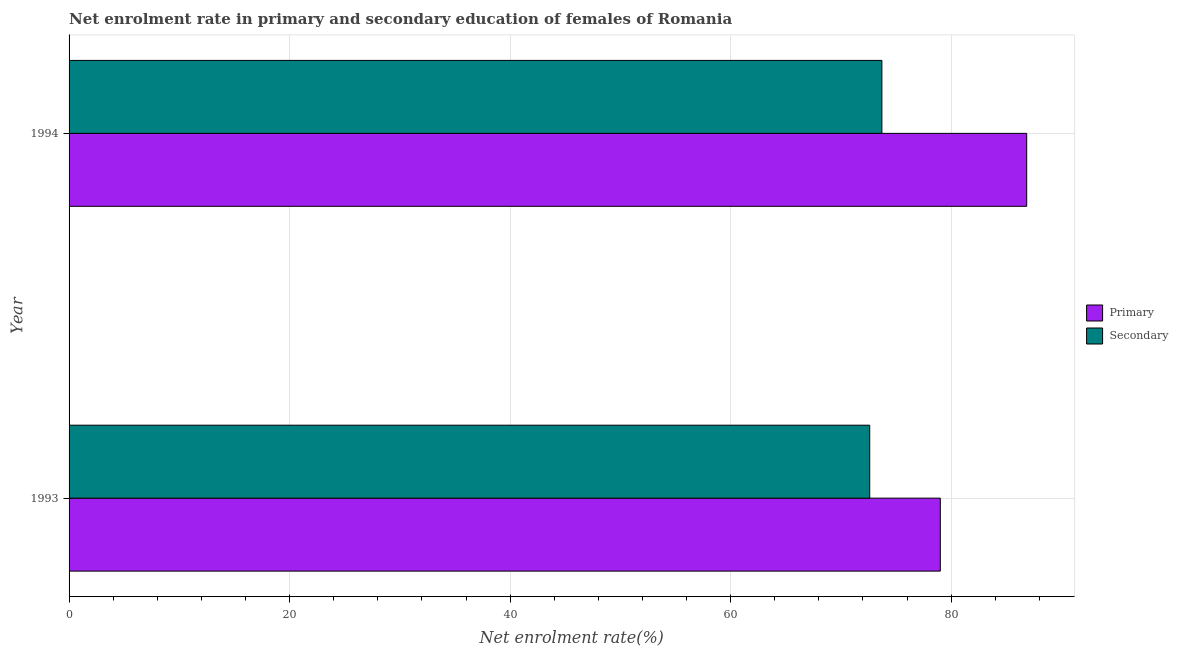How many groups of bars are there?
Make the answer very short. 2. Are the number of bars per tick equal to the number of legend labels?
Your answer should be compact. Yes. What is the enrollment rate in primary education in 1993?
Provide a short and direct response. 79.02. Across all years, what is the maximum enrollment rate in primary education?
Your answer should be very brief. 86.86. Across all years, what is the minimum enrollment rate in primary education?
Ensure brevity in your answer.  79.02. In which year was the enrollment rate in primary education minimum?
Offer a very short reply. 1993. What is the total enrollment rate in primary education in the graph?
Your answer should be very brief. 165.88. What is the difference between the enrollment rate in secondary education in 1993 and that in 1994?
Your response must be concise. -1.1. What is the difference between the enrollment rate in secondary education in 1994 and the enrollment rate in primary education in 1993?
Ensure brevity in your answer.  -5.3. What is the average enrollment rate in secondary education per year?
Your answer should be very brief. 73.17. In the year 1994, what is the difference between the enrollment rate in primary education and enrollment rate in secondary education?
Ensure brevity in your answer.  13.13. In how many years, is the enrollment rate in secondary education greater than 60 %?
Your response must be concise. 2. What is the ratio of the enrollment rate in primary education in 1993 to that in 1994?
Make the answer very short. 0.91. What does the 1st bar from the top in 1994 represents?
Ensure brevity in your answer.  Secondary. What does the 2nd bar from the bottom in 1994 represents?
Your answer should be very brief. Secondary. How many bars are there?
Offer a very short reply. 4. How many years are there in the graph?
Ensure brevity in your answer.  2. Are the values on the major ticks of X-axis written in scientific E-notation?
Your answer should be compact. No. How many legend labels are there?
Ensure brevity in your answer.  2. How are the legend labels stacked?
Offer a terse response. Vertical. What is the title of the graph?
Give a very brief answer. Net enrolment rate in primary and secondary education of females of Romania. Does "Resident workers" appear as one of the legend labels in the graph?
Provide a succinct answer. No. What is the label or title of the X-axis?
Ensure brevity in your answer.  Net enrolment rate(%). What is the label or title of the Y-axis?
Ensure brevity in your answer.  Year. What is the Net enrolment rate(%) in Primary in 1993?
Your answer should be compact. 79.02. What is the Net enrolment rate(%) of Secondary in 1993?
Offer a terse response. 72.62. What is the Net enrolment rate(%) of Primary in 1994?
Give a very brief answer. 86.86. What is the Net enrolment rate(%) of Secondary in 1994?
Provide a succinct answer. 73.72. Across all years, what is the maximum Net enrolment rate(%) of Primary?
Provide a succinct answer. 86.86. Across all years, what is the maximum Net enrolment rate(%) in Secondary?
Keep it short and to the point. 73.72. Across all years, what is the minimum Net enrolment rate(%) in Primary?
Your response must be concise. 79.02. Across all years, what is the minimum Net enrolment rate(%) of Secondary?
Provide a short and direct response. 72.62. What is the total Net enrolment rate(%) of Primary in the graph?
Your answer should be compact. 165.88. What is the total Net enrolment rate(%) of Secondary in the graph?
Ensure brevity in your answer.  146.34. What is the difference between the Net enrolment rate(%) of Primary in 1993 and that in 1994?
Give a very brief answer. -7.84. What is the difference between the Net enrolment rate(%) of Secondary in 1993 and that in 1994?
Give a very brief answer. -1.1. What is the difference between the Net enrolment rate(%) in Primary in 1993 and the Net enrolment rate(%) in Secondary in 1994?
Your answer should be very brief. 5.3. What is the average Net enrolment rate(%) in Primary per year?
Offer a very short reply. 82.94. What is the average Net enrolment rate(%) of Secondary per year?
Offer a terse response. 73.17. In the year 1993, what is the difference between the Net enrolment rate(%) in Primary and Net enrolment rate(%) in Secondary?
Make the answer very short. 6.4. In the year 1994, what is the difference between the Net enrolment rate(%) of Primary and Net enrolment rate(%) of Secondary?
Your answer should be very brief. 13.13. What is the ratio of the Net enrolment rate(%) of Primary in 1993 to that in 1994?
Your answer should be very brief. 0.91. What is the difference between the highest and the second highest Net enrolment rate(%) in Primary?
Your answer should be compact. 7.84. What is the difference between the highest and the second highest Net enrolment rate(%) in Secondary?
Keep it short and to the point. 1.1. What is the difference between the highest and the lowest Net enrolment rate(%) of Primary?
Keep it short and to the point. 7.84. What is the difference between the highest and the lowest Net enrolment rate(%) in Secondary?
Ensure brevity in your answer.  1.1. 